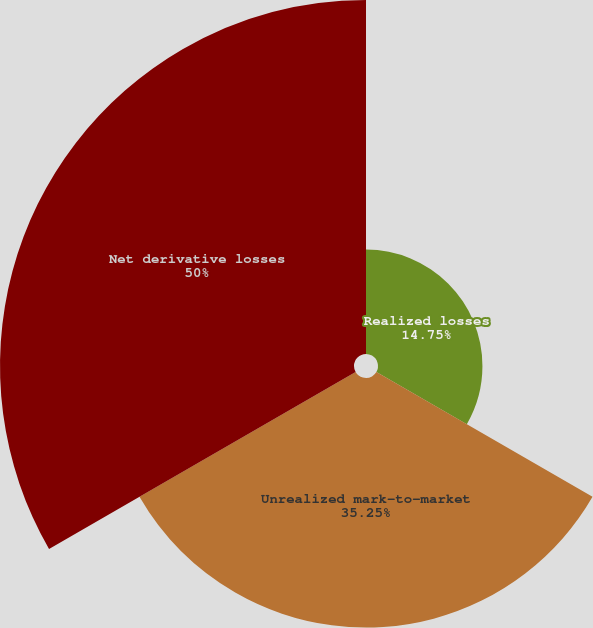Convert chart. <chart><loc_0><loc_0><loc_500><loc_500><pie_chart><fcel>Realized losses<fcel>Unrealized mark-to-market<fcel>Net derivative losses<nl><fcel>14.75%<fcel>35.25%<fcel>50.0%<nl></chart> 